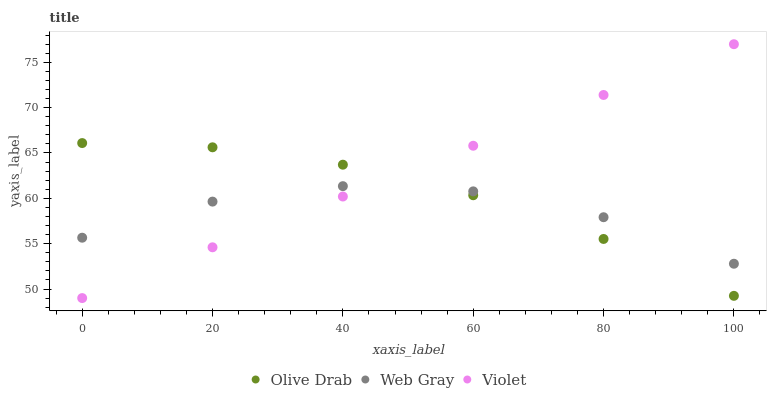Does Web Gray have the minimum area under the curve?
Answer yes or no. Yes. Does Violet have the maximum area under the curve?
Answer yes or no. Yes. Does Olive Drab have the minimum area under the curve?
Answer yes or no. No. Does Olive Drab have the maximum area under the curve?
Answer yes or no. No. Is Violet the smoothest?
Answer yes or no. Yes. Is Web Gray the roughest?
Answer yes or no. Yes. Is Olive Drab the smoothest?
Answer yes or no. No. Is Olive Drab the roughest?
Answer yes or no. No. Does Violet have the lowest value?
Answer yes or no. Yes. Does Olive Drab have the lowest value?
Answer yes or no. No. Does Violet have the highest value?
Answer yes or no. Yes. Does Olive Drab have the highest value?
Answer yes or no. No. Does Olive Drab intersect Violet?
Answer yes or no. Yes. Is Olive Drab less than Violet?
Answer yes or no. No. Is Olive Drab greater than Violet?
Answer yes or no. No. 